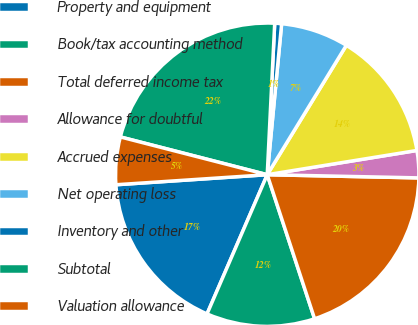<chart> <loc_0><loc_0><loc_500><loc_500><pie_chart><fcel>Property and equipment<fcel>Book/tax accounting method<fcel>Total deferred income tax<fcel>Allowance for doubtful<fcel>Accrued expenses<fcel>Net operating loss<fcel>Inventory and other<fcel>Subtotal<fcel>Valuation allowance<nl><fcel>17.45%<fcel>11.55%<fcel>19.61%<fcel>2.89%<fcel>13.71%<fcel>7.22%<fcel>0.73%<fcel>21.78%<fcel>5.06%<nl></chart> 